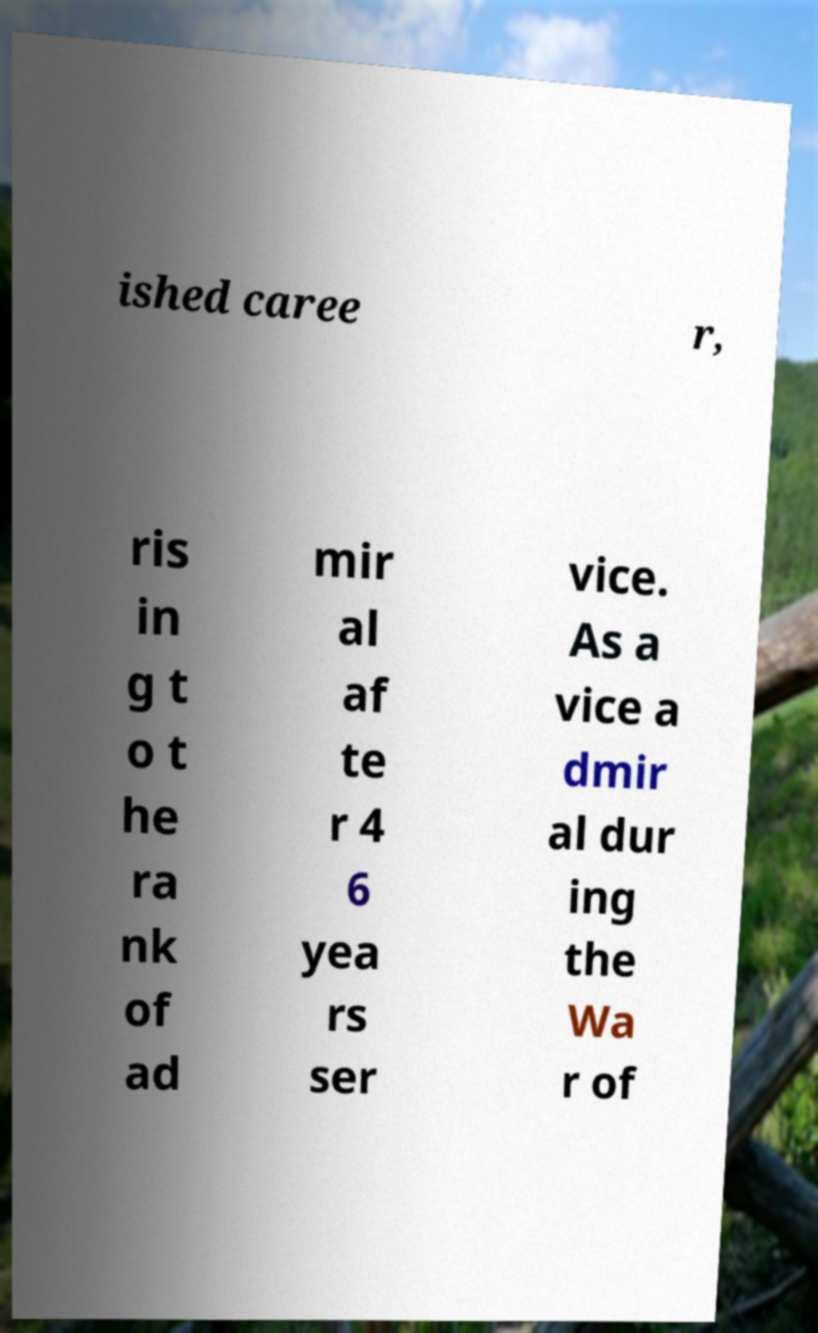What messages or text are displayed in this image? I need them in a readable, typed format. ished caree r, ris in g t o t he ra nk of ad mir al af te r 4 6 yea rs ser vice. As a vice a dmir al dur ing the Wa r of 